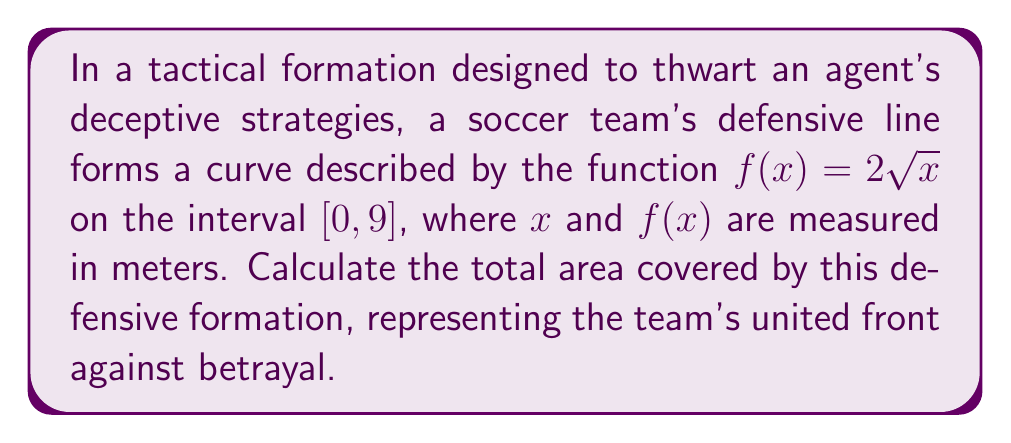Give your solution to this math problem. To find the area covered by the defensive formation, we need to integrate the function $f(x) = 2\sqrt{x}$ over the interval $[0, 9]$. This can be done using the following steps:

1) The area is given by the definite integral:

   $$A = \int_0^9 2\sqrt{x} dx$$

2) To integrate $\sqrt{x}$, we can use the power rule with a fractional exponent:
   
   $\int x^n dx = \frac{x^{n+1}}{n+1} + C$, where $n \neq -1$
   
   Here, $\sqrt{x} = x^{\frac{1}{2}}$, so $n = \frac{1}{2}$

3) Applying this rule:

   $$\int 2\sqrt{x} dx = 2 \int x^{\frac{1}{2}} dx = 2 \cdot \frac{x^{\frac{3}{2}}}{\frac{3}{2}} + C = \frac{4}{3}x^{\frac{3}{2}} + C$$

4) Now we can evaluate the definite integral:

   $$A = \left[\frac{4}{3}x^{\frac{3}{2}}\right]_0^9$$

5) Substituting the limits:

   $$A = \frac{4}{3}(9^{\frac{3}{2}}) - \frac{4}{3}(0^{\frac{3}{2}})$$

6) Simplify:
   
   $$A = \frac{4}{3}(27) - 0 = 36$$

Therefore, the total area covered by the defensive formation is 36 square meters.
Answer: 36 square meters 